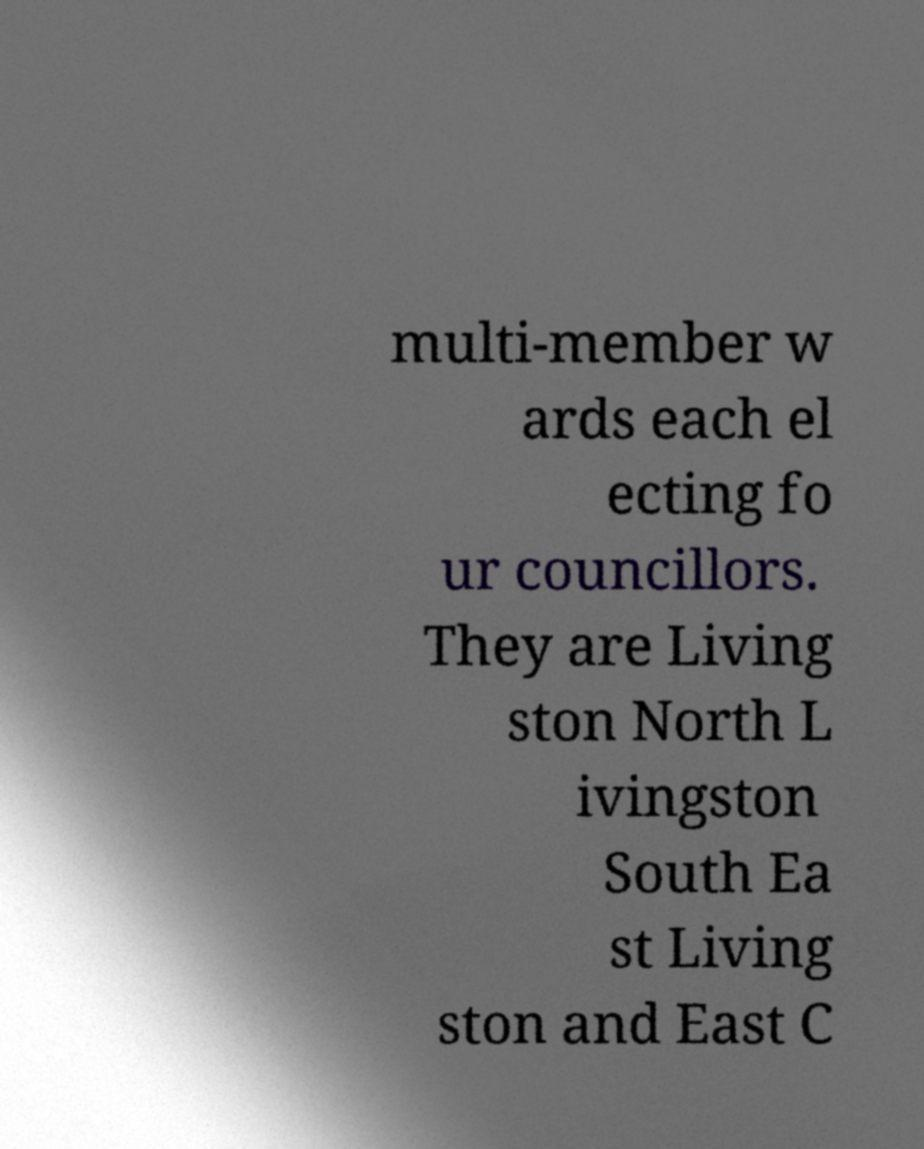What messages or text are displayed in this image? I need them in a readable, typed format. multi-member w ards each el ecting fo ur councillors. They are Living ston North L ivingston South Ea st Living ston and East C 